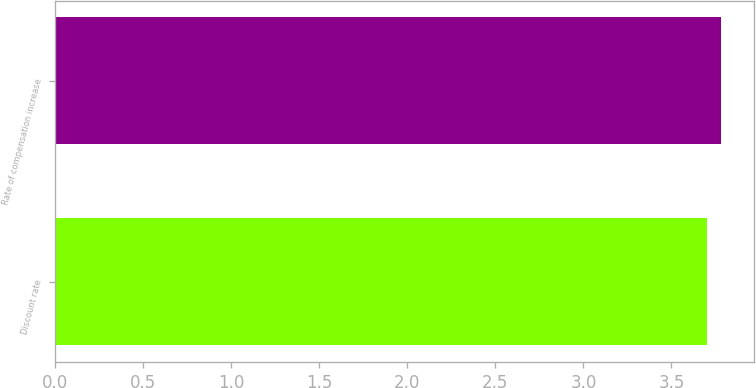<chart> <loc_0><loc_0><loc_500><loc_500><bar_chart><fcel>Discount rate<fcel>Rate of compensation increase<nl><fcel>3.7<fcel>3.78<nl></chart> 